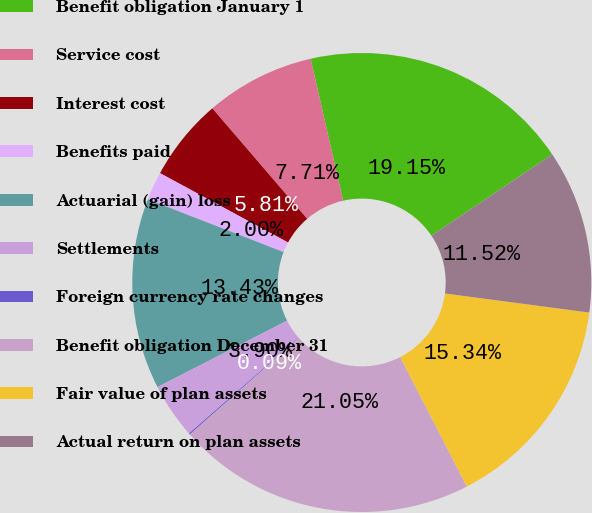<chart> <loc_0><loc_0><loc_500><loc_500><pie_chart><fcel>Benefit obligation January 1<fcel>Service cost<fcel>Interest cost<fcel>Benefits paid<fcel>Actuarial (gain) loss<fcel>Settlements<fcel>Foreign currency rate changes<fcel>Benefit obligation December 31<fcel>Fair value of plan assets<fcel>Actual return on plan assets<nl><fcel>19.15%<fcel>7.71%<fcel>5.81%<fcel>2.0%<fcel>13.43%<fcel>3.9%<fcel>0.09%<fcel>21.05%<fcel>15.34%<fcel>11.52%<nl></chart> 